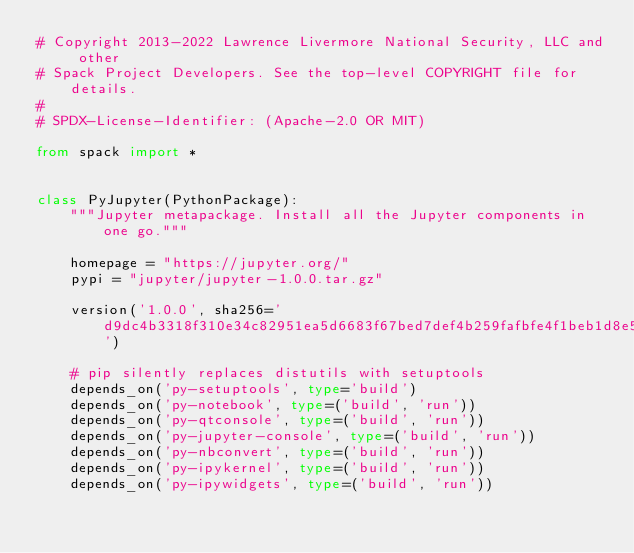<code> <loc_0><loc_0><loc_500><loc_500><_Python_># Copyright 2013-2022 Lawrence Livermore National Security, LLC and other
# Spack Project Developers. See the top-level COPYRIGHT file for details.
#
# SPDX-License-Identifier: (Apache-2.0 OR MIT)

from spack import *


class PyJupyter(PythonPackage):
    """Jupyter metapackage. Install all the Jupyter components in one go."""

    homepage = "https://jupyter.org/"
    pypi = "jupyter/jupyter-1.0.0.tar.gz"

    version('1.0.0', sha256='d9dc4b3318f310e34c82951ea5d6683f67bed7def4b259fafbfe4f1beb1d8e5f')

    # pip silently replaces distutils with setuptools
    depends_on('py-setuptools', type='build')
    depends_on('py-notebook', type=('build', 'run'))
    depends_on('py-qtconsole', type=('build', 'run'))
    depends_on('py-jupyter-console', type=('build', 'run'))
    depends_on('py-nbconvert', type=('build', 'run'))
    depends_on('py-ipykernel', type=('build', 'run'))
    depends_on('py-ipywidgets', type=('build', 'run'))
</code> 